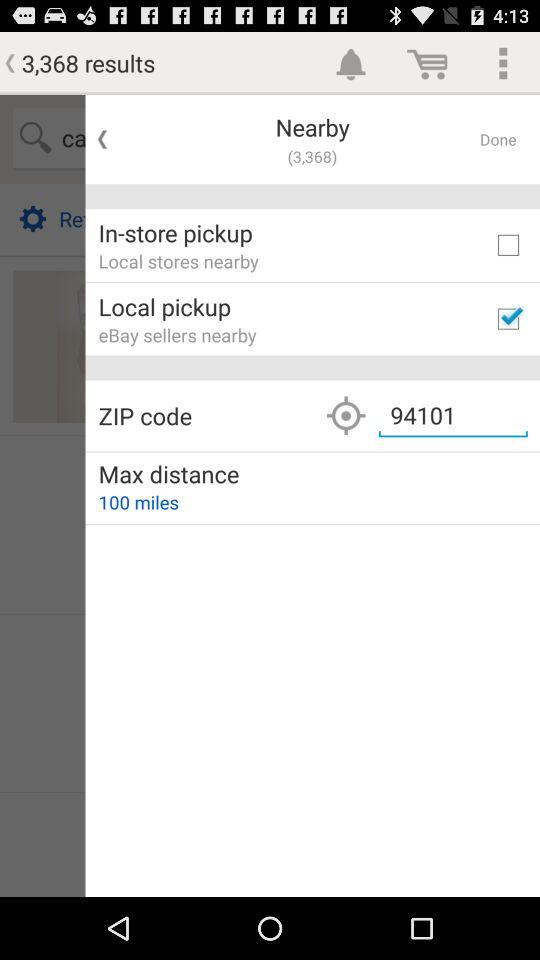How many miles is the maximum distance?
Answer the question using a single word or phrase. 100 